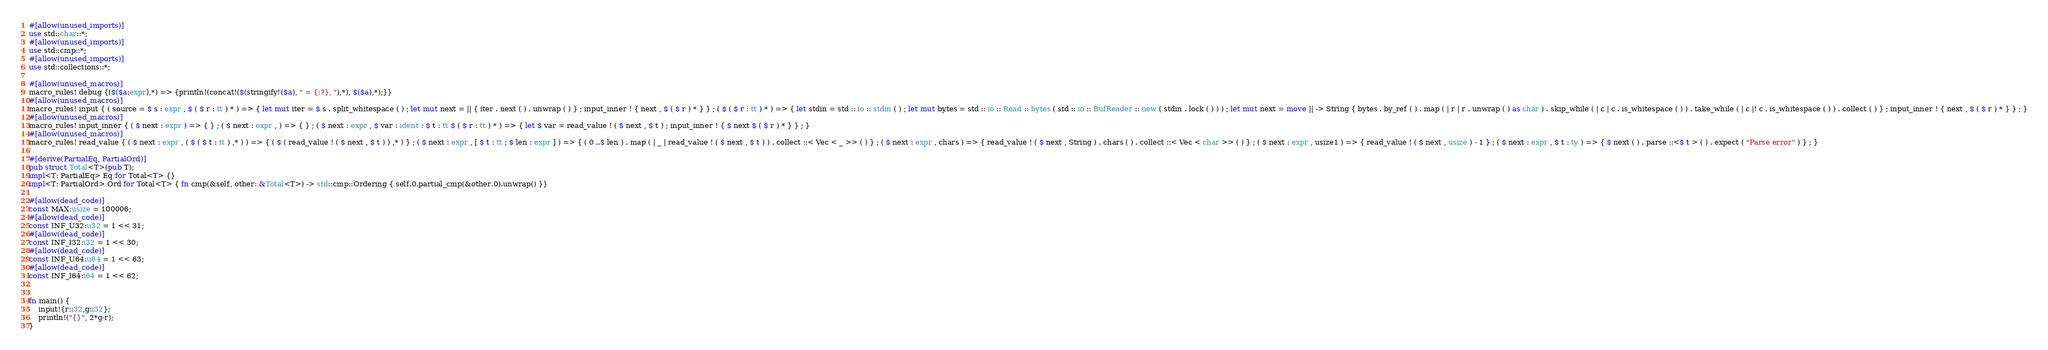Convert code to text. <code><loc_0><loc_0><loc_500><loc_500><_Rust_>#[allow(unused_imports)]
use std::char::*;
#[allow(unused_imports)]
use std::cmp::*;
#[allow(unused_imports)]
use std::collections::*;

#[allow(unused_macros)]
macro_rules! debug {($($a:expr),*) => {println!(concat!($(stringify!($a), " = {:?}, "),*), $($a),*);}}
#[allow(unused_macros)]
macro_rules! input { ( source = $ s : expr , $ ( $ r : tt ) * ) => { let mut iter = $ s . split_whitespace ( ) ; let mut next = || { iter . next ( ) . unwrap ( ) } ; input_inner ! { next , $ ( $ r ) * } } ; ( $ ( $ r : tt ) * ) => { let stdin = std :: io :: stdin ( ) ; let mut bytes = std :: io :: Read :: bytes ( std :: io :: BufReader :: new ( stdin . lock ( ) ) ) ; let mut next = move || -> String { bytes . by_ref ( ) . map ( | r | r . unwrap ( ) as char ) . skip_while ( | c | c . is_whitespace ( ) ) . take_while ( | c |! c . is_whitespace ( ) ) . collect ( ) } ; input_inner ! { next , $ ( $ r ) * } } ; }
#[allow(unused_macros)]
macro_rules! input_inner { ( $ next : expr ) => { } ; ( $ next : expr , ) => { } ; ( $ next : expr , $ var : ident : $ t : tt $ ( $ r : tt ) * ) => { let $ var = read_value ! ( $ next , $ t ) ; input_inner ! { $ next $ ( $ r ) * } } ; }
#[allow(unused_macros)]
macro_rules! read_value { ( $ next : expr , ( $ ( $ t : tt ) ,* ) ) => { ( $ ( read_value ! ( $ next , $ t ) ) ,* ) } ; ( $ next : expr , [ $ t : tt ; $ len : expr ] ) => { ( 0 ..$ len ) . map ( | _ | read_value ! ( $ next , $ t ) ) . collect ::< Vec < _ >> ( ) } ; ( $ next : expr , chars ) => { read_value ! ( $ next , String ) . chars ( ) . collect ::< Vec < char >> ( ) } ; ( $ next : expr , usize1 ) => { read_value ! ( $ next , usize ) - 1 } ; ( $ next : expr , $ t : ty ) => { $ next ( ) . parse ::<$ t > ( ) . expect ( "Parse error" ) } ; }

#[derive(PartialEq, PartialOrd)]
pub struct Total<T>(pub T);
impl<T: PartialEq> Eq for Total<T> {}
impl<T: PartialOrd> Ord for Total<T> { fn cmp(&self, other: &Total<T>) -> std::cmp::Ordering { self.0.partial_cmp(&other.0).unwrap() }}

#[allow(dead_code)]
const MAX:usize = 100006;
#[allow(dead_code)]
const INF_U32:u32 = 1 << 31;
#[allow(dead_code)]
const INF_I32:i32 = 1 << 30;
#[allow(dead_code)]
const INF_U64:u64 = 1 << 63;
#[allow(dead_code)]
const INF_I64:i64 = 1 << 62;


fn main() {
    input!{r:i32,g:i32};
    println!("{}", 2*g-r);
}</code> 